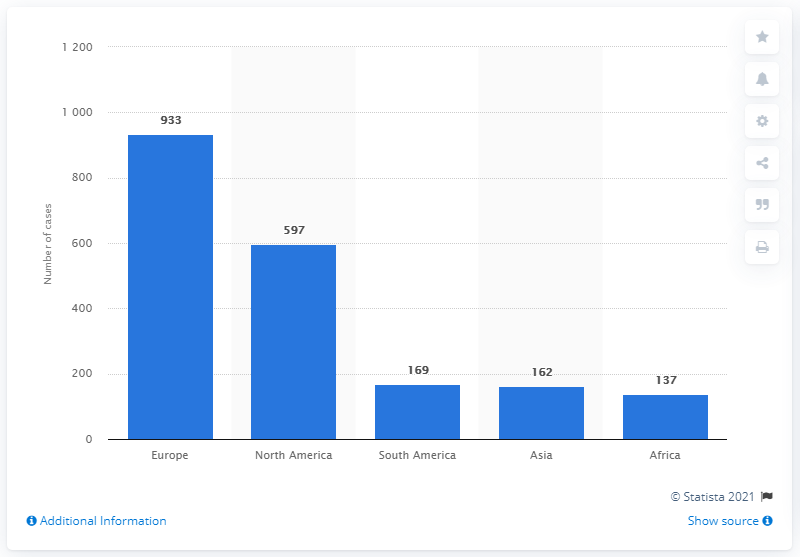Indicate a few pertinent items in this graphic. During the period of 2000 to 2010, a total of 169 doping cases were reported in South America. 